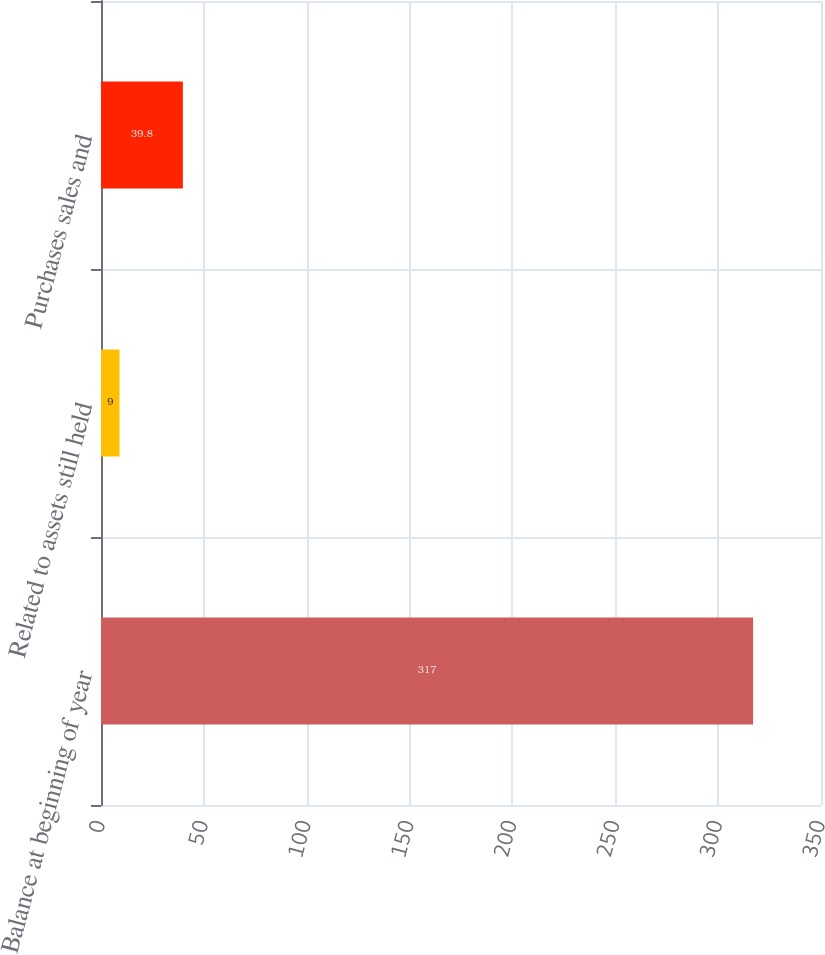Convert chart. <chart><loc_0><loc_0><loc_500><loc_500><bar_chart><fcel>Balance at beginning of year<fcel>Related to assets still held<fcel>Purchases sales and<nl><fcel>317<fcel>9<fcel>39.8<nl></chart> 